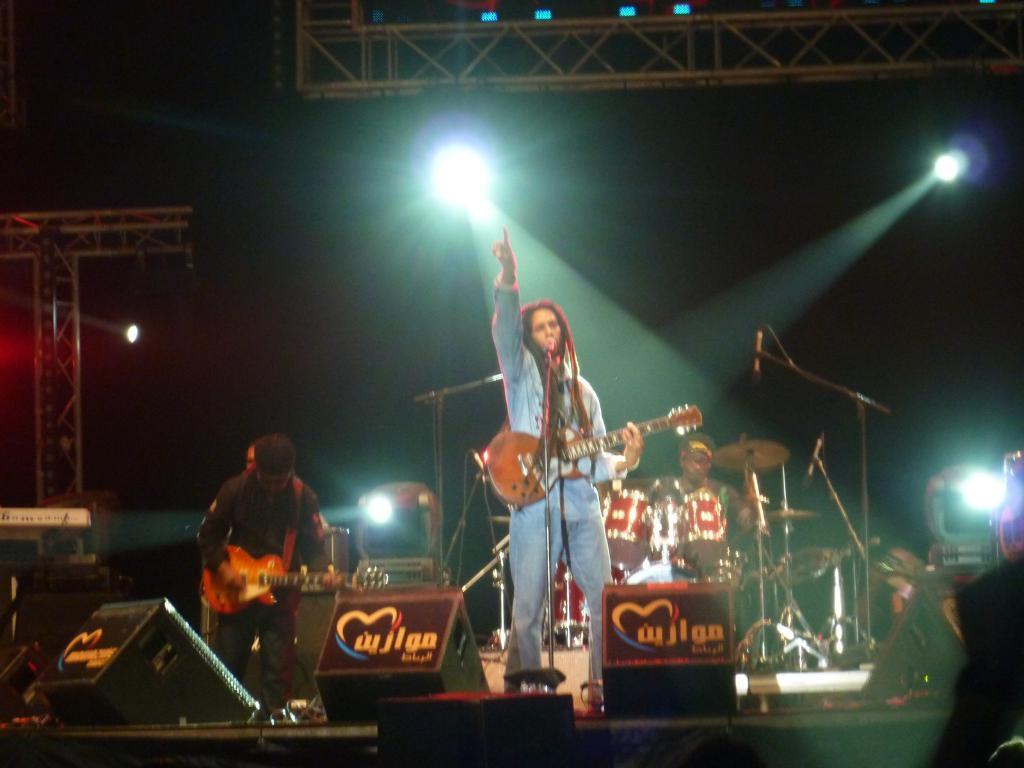In one or two sentences, can you explain what this image depicts? In this image I can see three men where two of them are standing and holding a guitar, in the background I can see he is sitting next to a drum set. I can also see few mice and few lights. 